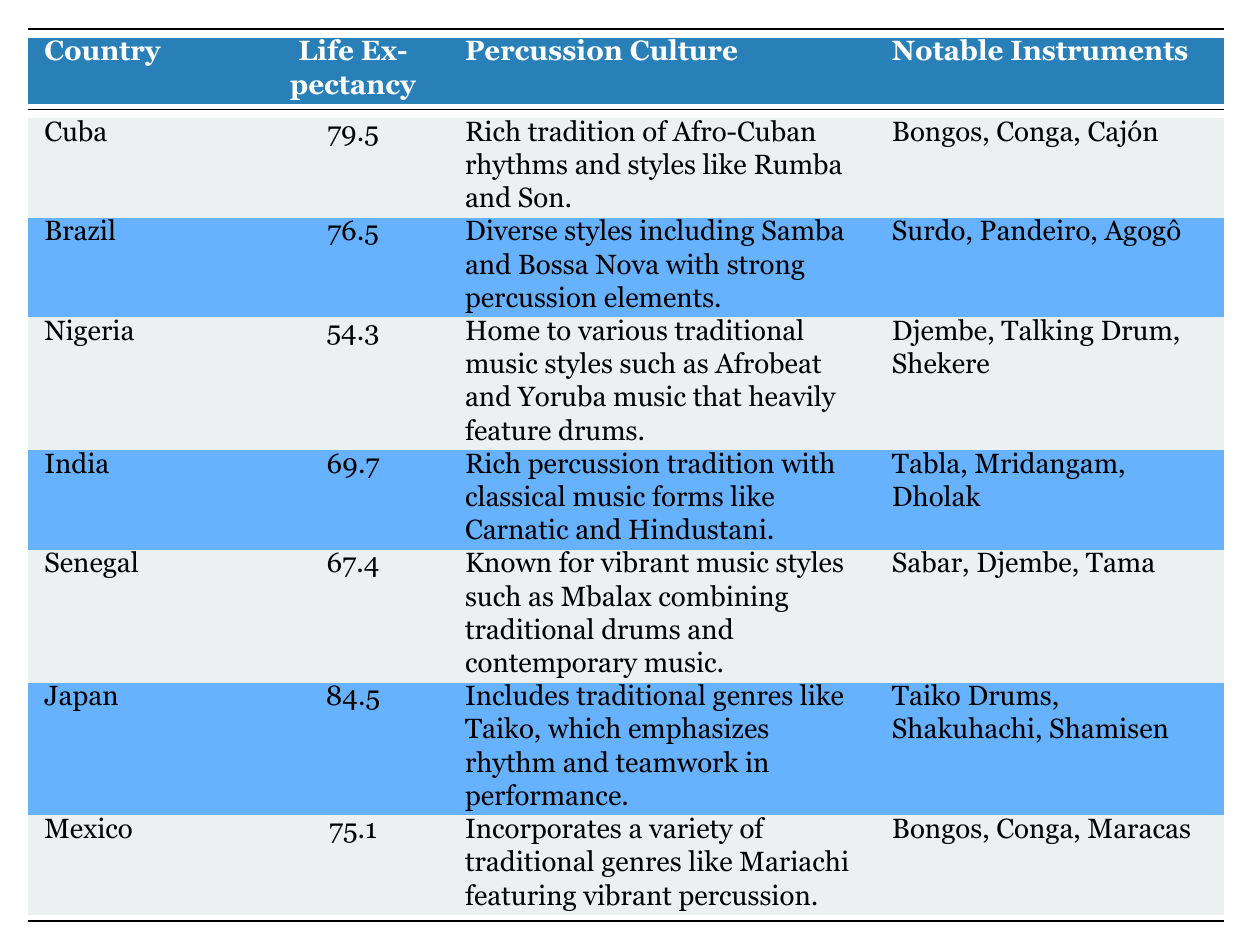What is the life expectancy of Japan? According to the table, the life expectancy listed for Japan is 84.5 years.
Answer: 84.5 Which country has the lowest life expectancy among those listed? By inspecting the life expectancy values, Nigeria has the lowest life expectancy at 54.3 years.
Answer: Nigeria Is Brazil's life expectancy greater than Mexico's? The life expectancy for Brazil is 76.5 years and for Mexico is 75.1 years. Since 76.5 is greater than 75.1, the answer is yes.
Answer: Yes What is the average life expectancy of the countries listed? To find the average life expectancy, sum all the values: (79.5 + 76.5 + 54.3 + 69.7 + 67.4 + 84.5 + 75.1) = 507.0. There are 7 countries, so the average is 507.0 / 7 = 72.43.
Answer: 72.43 Does any country listed have a life expectancy above 80 years? The only country with a life expectancy above 80 years is Japan at 84.5 years. Thus, the answer is yes.
Answer: Yes Which country has a rich percussion tradition and a life expectancy of over 70 years? Looking for countries with life expectancy over 70 years, we find Cuba (79.5), Brazil (76.5), India (69.7), and Japan (84.5). Of these, Cuba and Brazil particularly highlight rich percussion traditions, while India has a modest life expectancy. Therefore, only Cuba and Japan meet both criteria.
Answer: Cuba, Japan If you compare the life expectancies of Nigeria and Senegal, how much more does Senegal have? Senegal's life expectancy is 67.4 years and Nigeria’s is 54.3 years, so the difference is calculated as 67.4 - 54.3 = 13.1 years.
Answer: 13.1 What notable instruments are associated with India's percussion culture? The table lists the notable instruments associated with India's percussion culture as Tabla, Mridangam, and Dholak.
Answer: Tabla, Mridangam, Dholak Is the percussion culture in Nigeria more varied than in Mexico? The table describes Nigeria's percussion culture with a focus on various traditional music styles, while Mexico incorporates varied genres. However, Nigeria has a more pronounced traditional focus. Therefore, it implies Nigeria has a more varied percussion background in traditional contexts.
Answer: Yes 